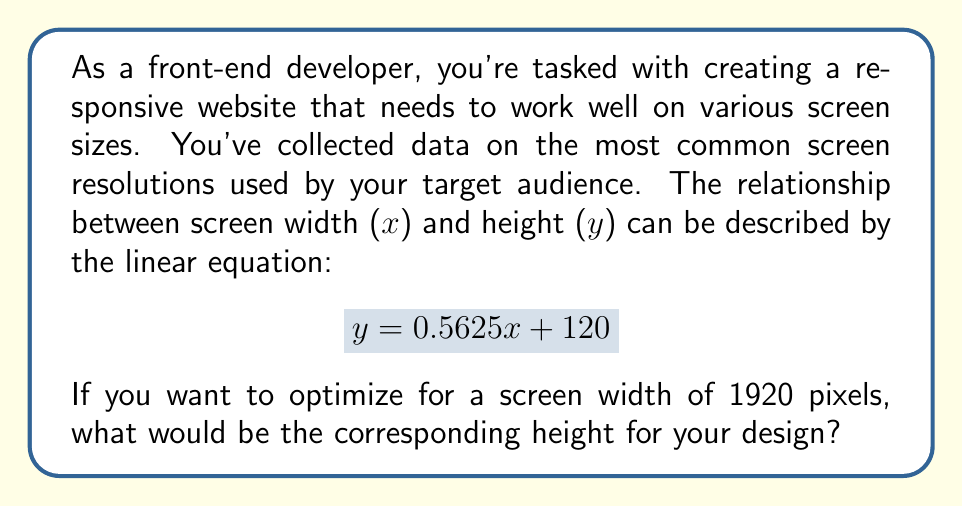Give your solution to this math problem. To solve this problem, we'll use the given linear equation and substitute the known value for x (screen width). Here's the step-by-step process:

1. We have the linear equation: $y = 0.5625x + 120$
   Where:
   - $y$ is the screen height in pixels
   - $x$ is the screen width in pixels
   - $0.5625$ is the slope (representing the aspect ratio)
   - $120$ is the y-intercept (a constant offset)

2. We know that we want to optimize for a screen width of 1920 pixels, so:
   $x = 1920$

3. Let's substitute this value into our equation:
   $y = 0.5625(1920) + 120$

4. Now, let's solve for y:
   $y = 1080 + 120$
   $y = 1200$

Therefore, for a screen width of 1920 pixels, the optimal screen height for your responsive design would be 1200 pixels.

Note: This result gives us a 16:10 aspect ratio, which is slightly taller than the common 16:9 (1920x1080) format. As a front-end developer, you might want to consider both this calculated value and the standard 1080p resolution when creating your responsive design.
Answer: $y = 1200$ pixels 